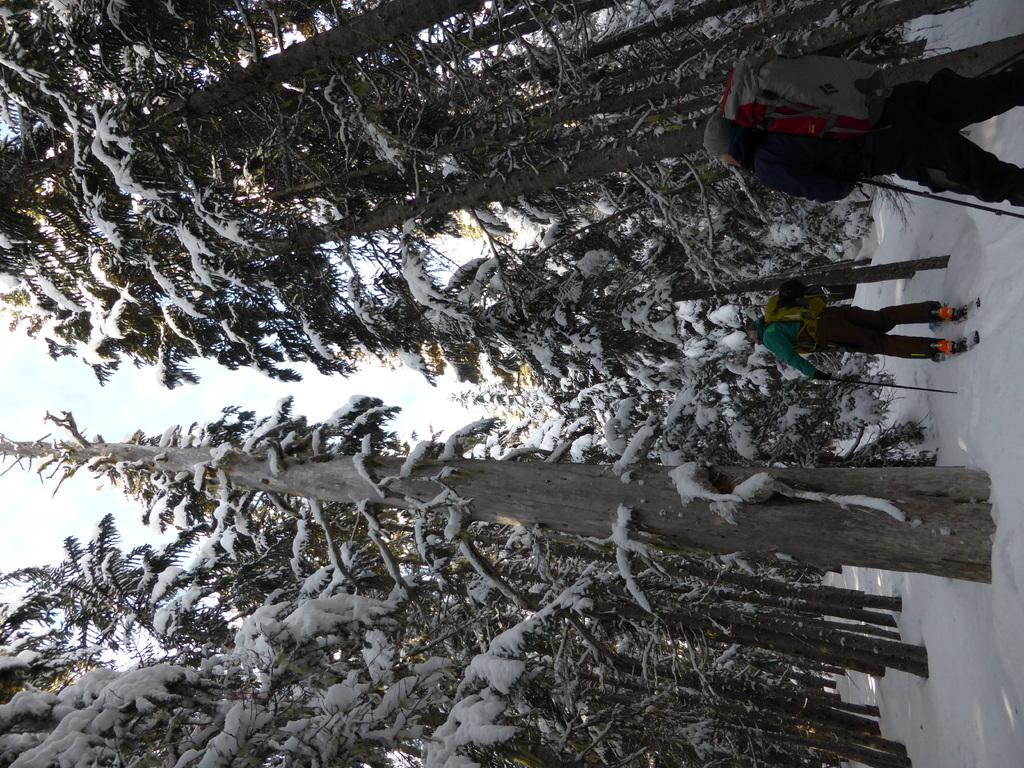How many people are in the image? There are two people in the image. What are the people wearing? The people are wearing bags. What are the people holding? The people are holding sticks. What is one person doing in the image? One person is standing on skis. What is the weather like in the image? There is snow visible in the image, and trees covered with snow are present, indicating a snowy environment. What is visible in the sky? The sky is visible in the image. What type of card can be seen being played by the people in the image? There is no card or card game present in the image; the people are holding sticks and one is standing on skis. 